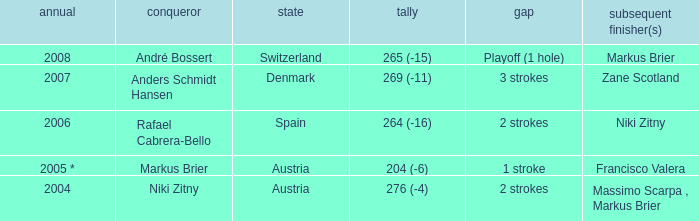Who was the runner-up when the year was 2008? Markus Brier. 